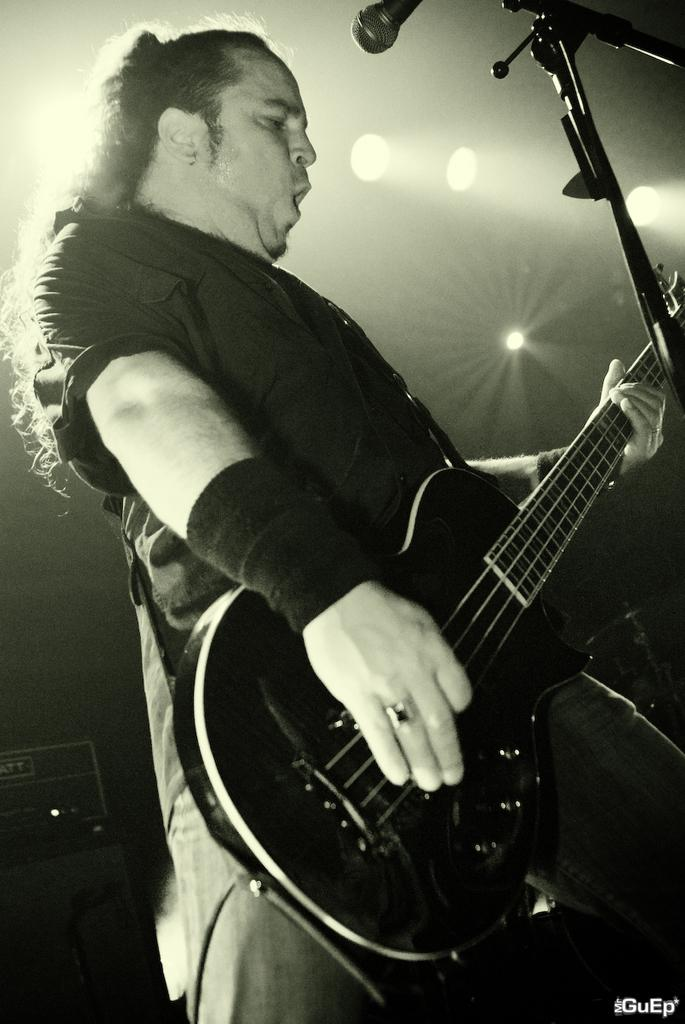What is the man in the image doing? The man is playing a guitar in the image. What object is present on the right side of the image? There is a microphone with a stand on the right side of the image. What can be seen in the background of the image? There are boxes and lights in the background of the image. What type of card is the man holding in the image? There is no card present in the image; the man is playing a guitar. Can you see any ants crawling on the microphone stand in the image? There are no ants present in the image. 